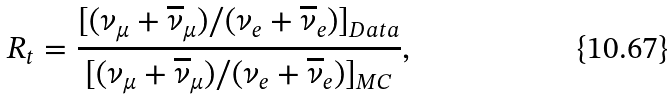Convert formula to latex. <formula><loc_0><loc_0><loc_500><loc_500>R _ { t } = \frac { [ ( \nu _ { \mu } + \overline { \nu } _ { \mu } ) / ( \nu _ { e } + \overline { \nu } _ { e } ) ] _ { D a t a } } { [ ( \nu _ { \mu } + \overline { \nu } _ { \mu } ) / ( \nu _ { e } + \overline { \nu } _ { e } ) ] _ { M C } } ,</formula> 